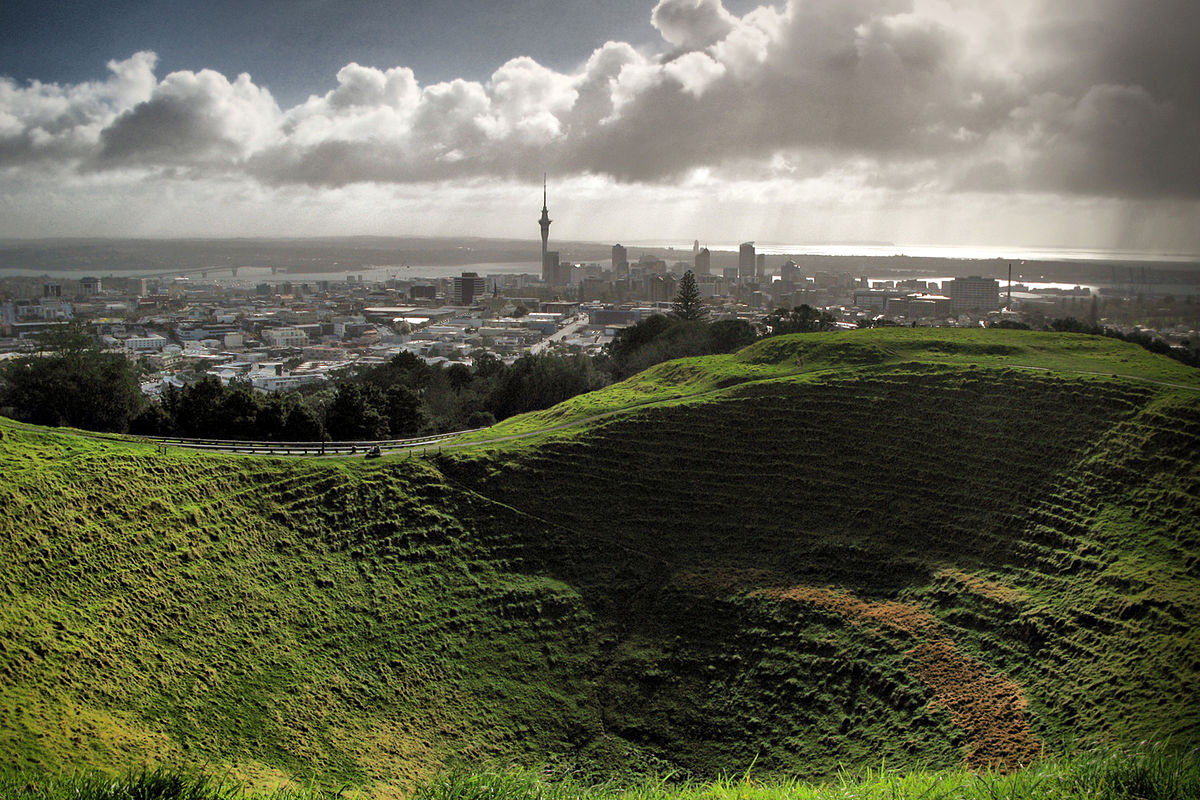What can you tell me about the historical significance of the Mt Eden Crater? Mt Eden Crater, also known as Maungawhau, holds great historical significance as a traditional fortified village, or pa, for the Maori people. This volcanic cone was used for its strategic vantage point over Auckland, and its fertile slopes were ideal for gardening. The area is steeped in cultural history, serving as an important meeting place and center of daily life for the local tribes. 